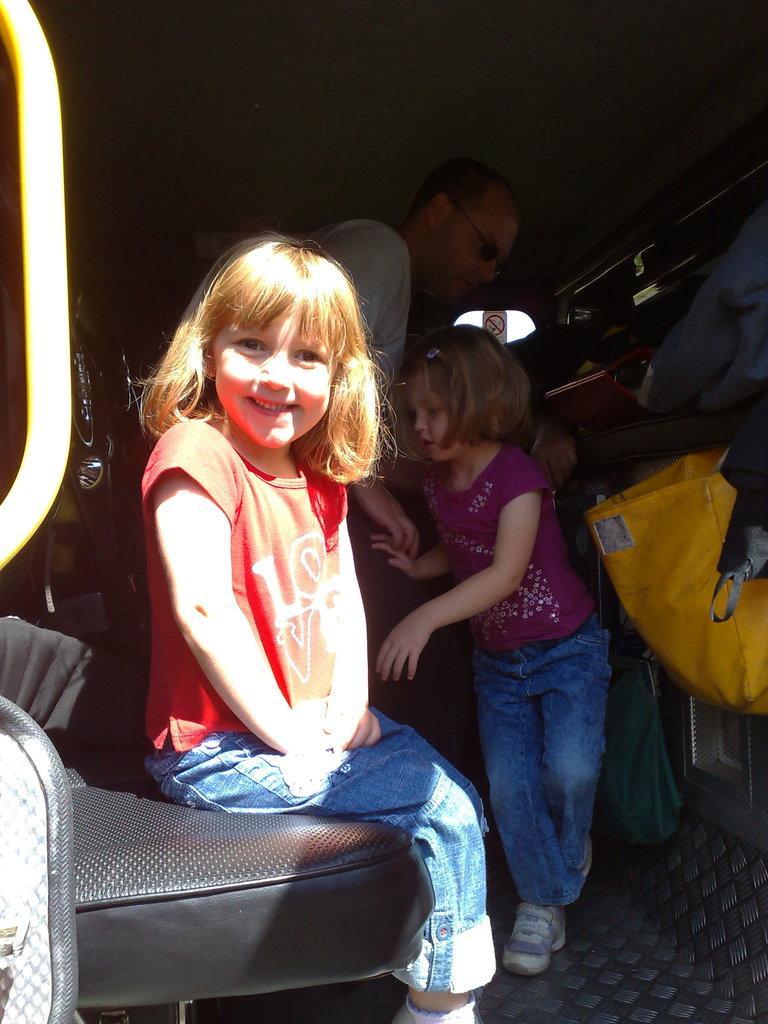Describe this image in one or two sentences. In this image we can see people standing on the floor and sitting on the sofa. In the background we can see cloth bags and a sign board. 